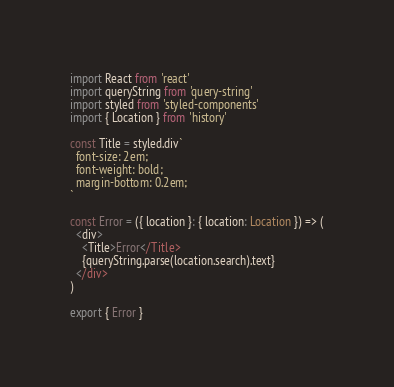Convert code to text. <code><loc_0><loc_0><loc_500><loc_500><_TypeScript_>import React from 'react'
import queryString from 'query-string'
import styled from 'styled-components'
import { Location } from 'history'

const Title = styled.div`
  font-size: 2em;
  font-weight: bold;
  margin-bottom: 0.2em;
`

const Error = ({ location }: { location: Location }) => (
  <div>
    <Title>Error</Title>
    {queryString.parse(location.search).text}
  </div>
)

export { Error }
</code> 